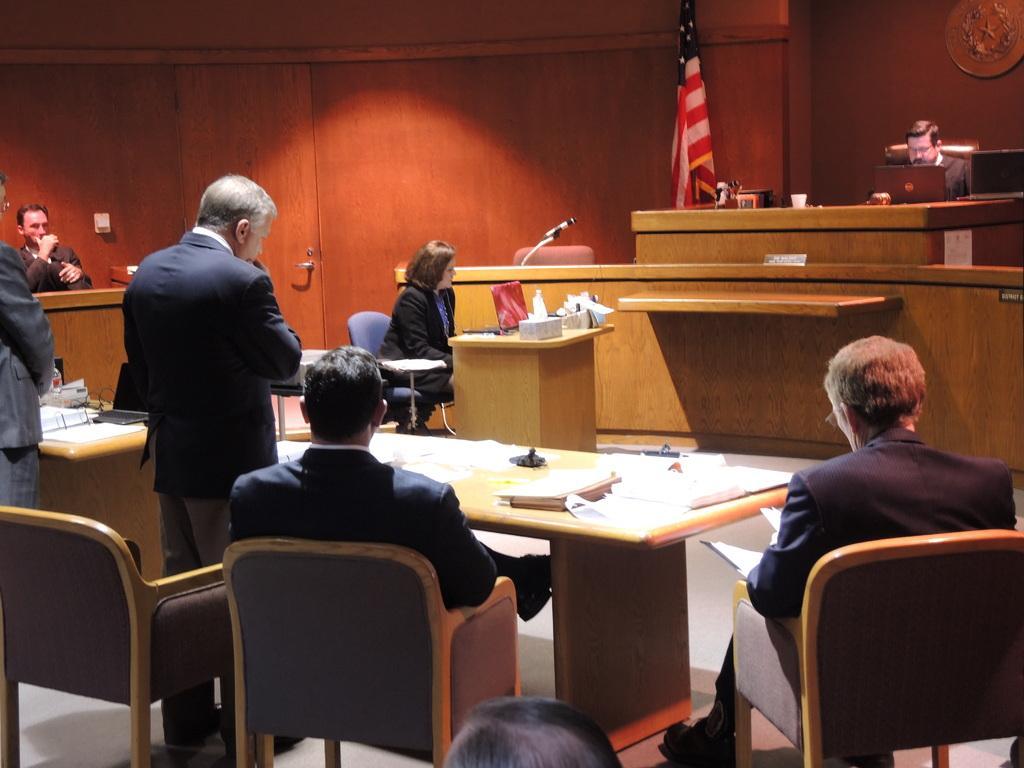Can you describe this image briefly? This picture describes about group of people, for are seated on the chair, and few are standing, in front of them we can find couple of books and boxes on the table, and you can see a man he is seated on the chair in front of him we can see a laptop cup on the table, in the background we can find a microphone, flag and a wall. 